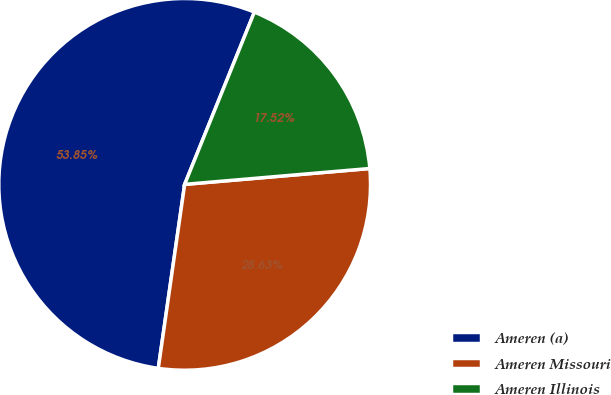Convert chart to OTSL. <chart><loc_0><loc_0><loc_500><loc_500><pie_chart><fcel>Ameren (a)<fcel>Ameren Missouri<fcel>Ameren Illinois<nl><fcel>53.86%<fcel>28.63%<fcel>17.52%<nl></chart> 